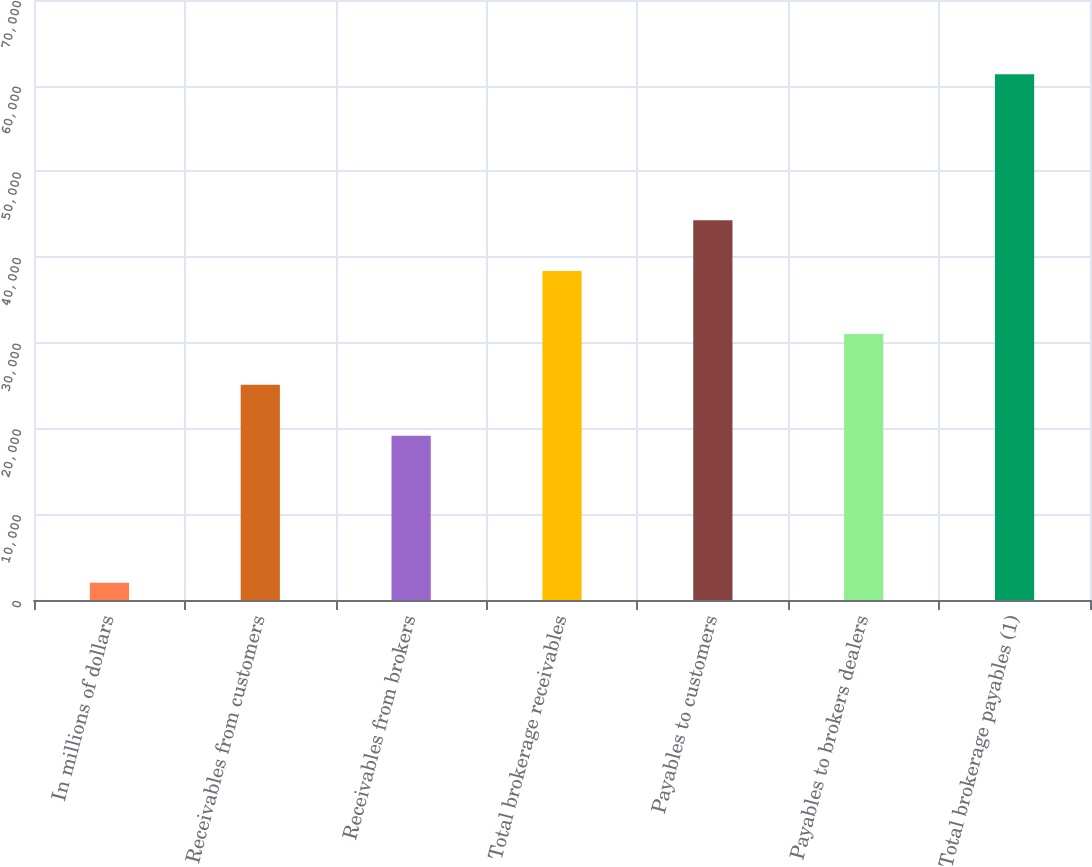Convert chart. <chart><loc_0><loc_0><loc_500><loc_500><bar_chart><fcel>In millions of dollars<fcel>Receivables from customers<fcel>Receivables from brokers<fcel>Total brokerage receivables<fcel>Payables to customers<fcel>Payables to brokers dealers<fcel>Total brokerage payables (1)<nl><fcel>2017<fcel>25101.5<fcel>19169<fcel>38384<fcel>44316.5<fcel>31034<fcel>61342<nl></chart> 